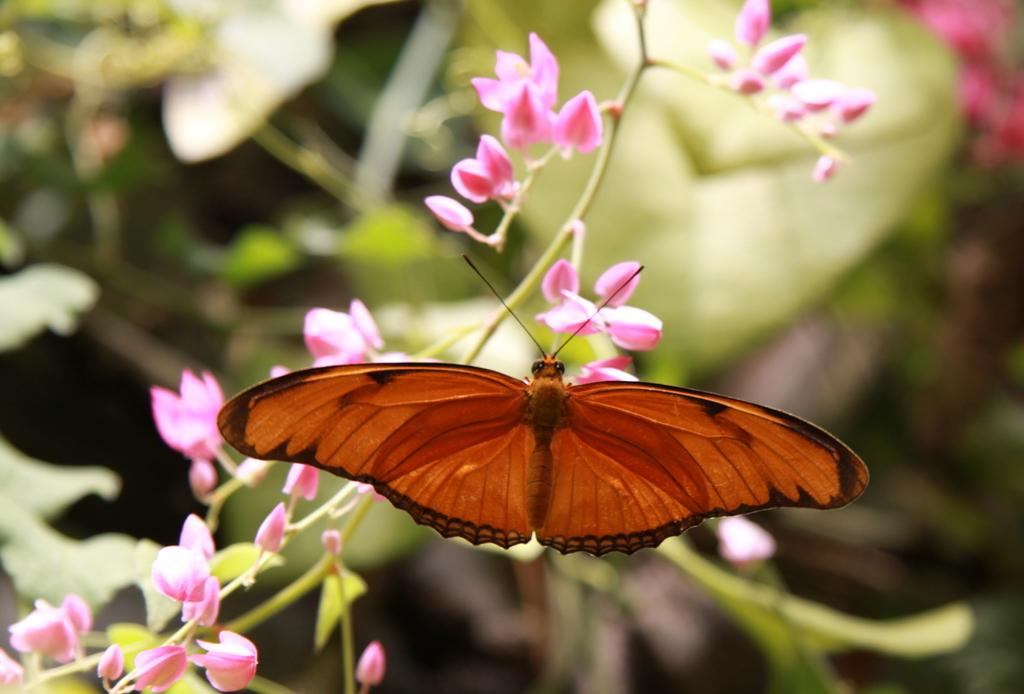What type of living organisms can be seen in the image? There are flowers and a butterfly in the image. Where is the butterfly located in the image? The butterfly is in the middle of the image. What is the background of the image like? The background of the image is blurry. What type of paper is the butterfly holding in the image? There is no paper present in the image, and the butterfly is not holding anything. 